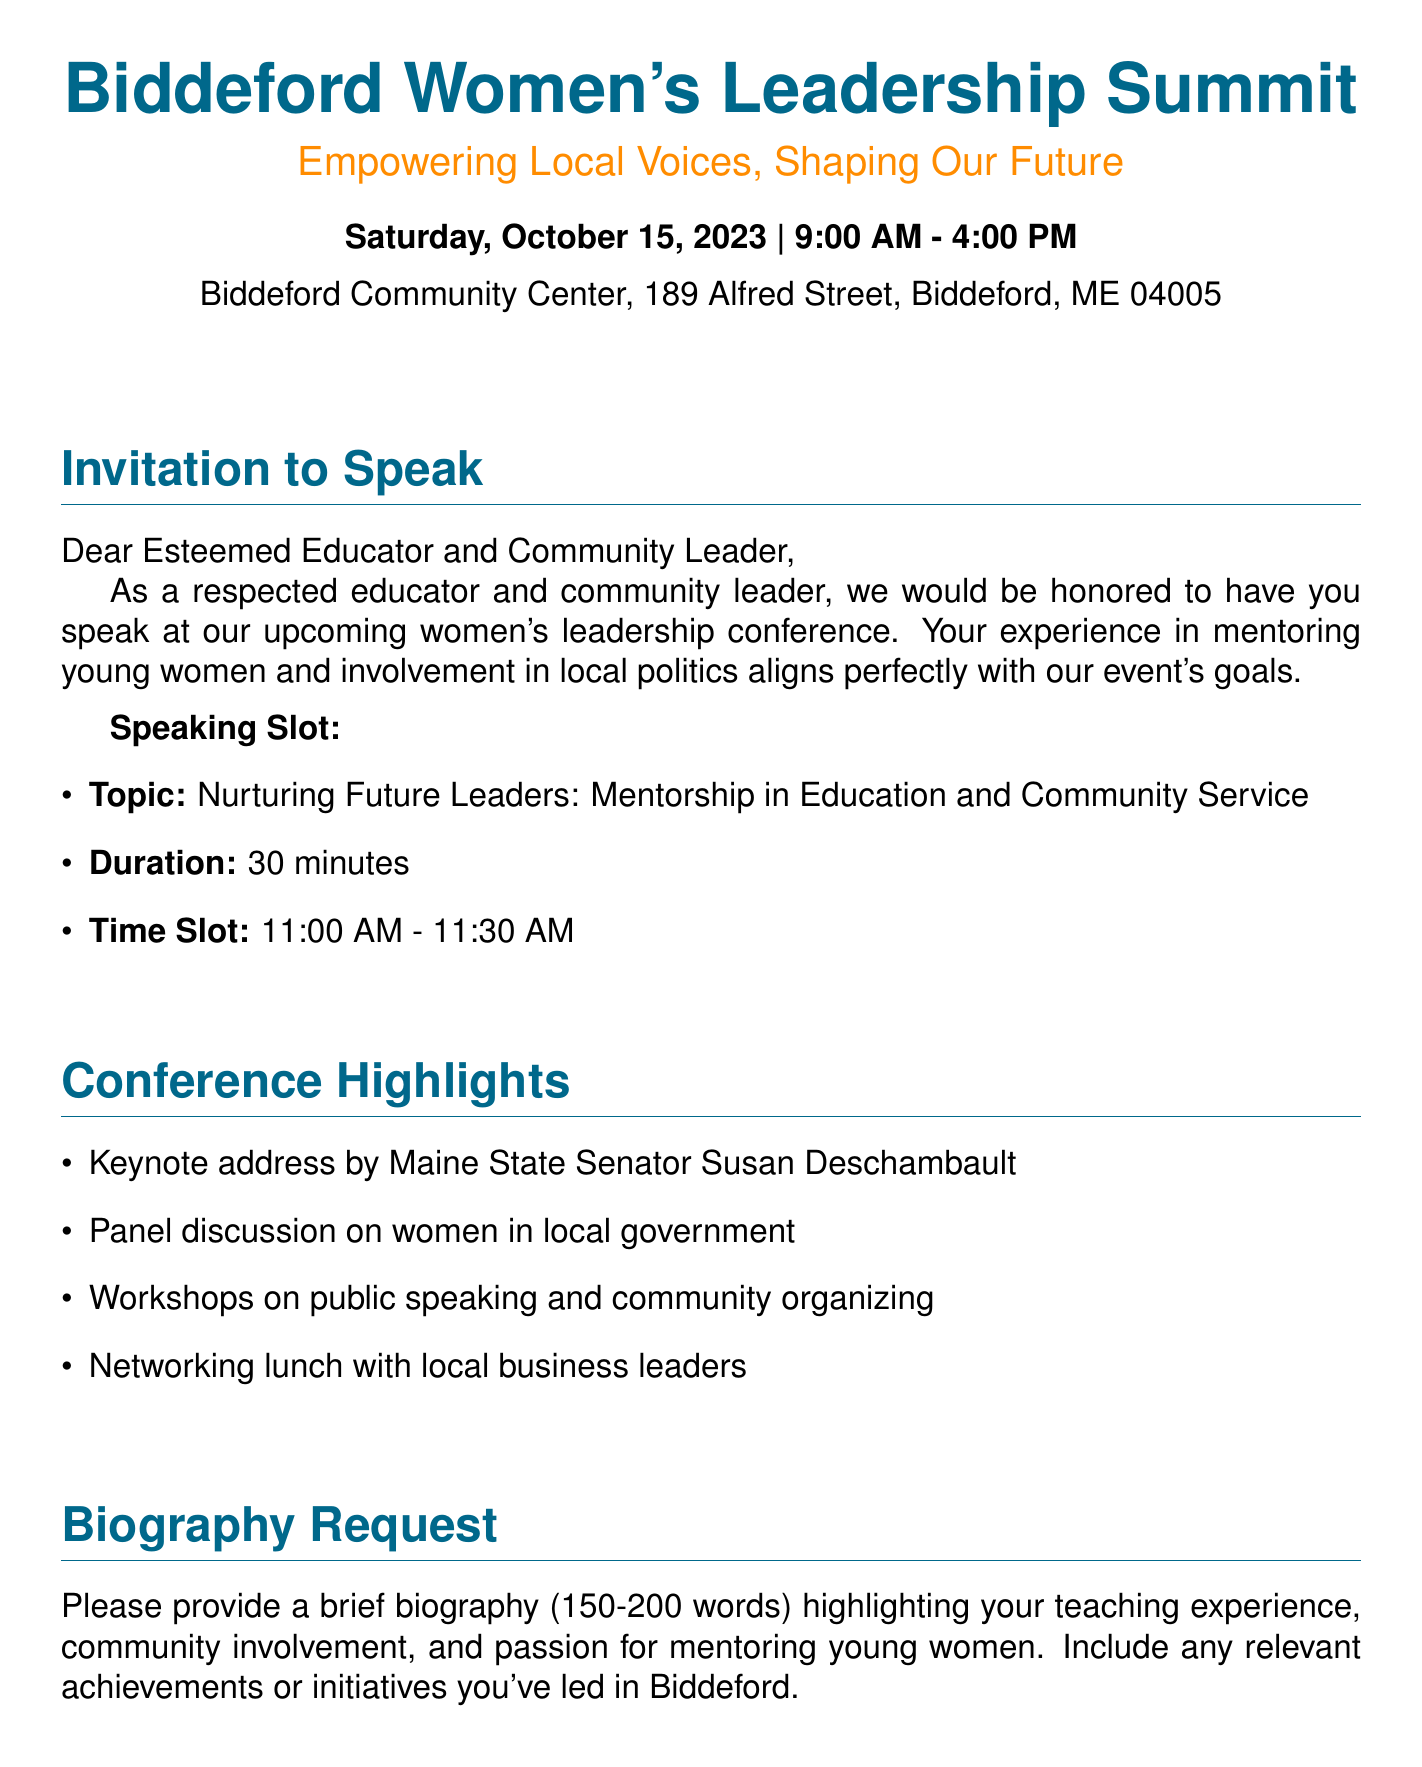What is the name of the event? The name of the event is explicitly provided in the document as "Biddeford Women's Leadership Summit."
Answer: Biddeford Women's Leadership Summit When is the event scheduled to take place? The document states the date of the event as "Saturday, October 15, 2023."
Answer: Saturday, October 15, 2023 What time does the event start? The document mentions that the event starts at "9:00 AM."
Answer: 9:00 AM Who is the contact person for the event? The document lists "Emily Rousseau" as the contact person for the event.
Answer: Emily Rousseau What topic will the speaker address? The document specifies the topic of the speech as "Nurturing Future Leaders: Mentorship in Education and Community Service."
Answer: Nurturing Future Leaders: Mentorship in Education and Community Service How long is the speaking duration? The duration of the speaking slot is indicated as "30 minutes" in the document.
Answer: 30 minutes Which senator is mentioned in the conference highlights? The document includes "Maine State Senator Susan Deschambault" as a highlight.
Answer: Maine State Senator Susan Deschambault What is requested in the biography? The document requests a brief biography highlighting teaching experience, community involvement, and passion for mentoring young women.
Answer: A brief biography (150-200 words) What is the theme of the event? The theme of the event is stated as "Empowering Local Voices, Shaping Our Future."
Answer: Empowering Local Voices, Shaping Our Future 